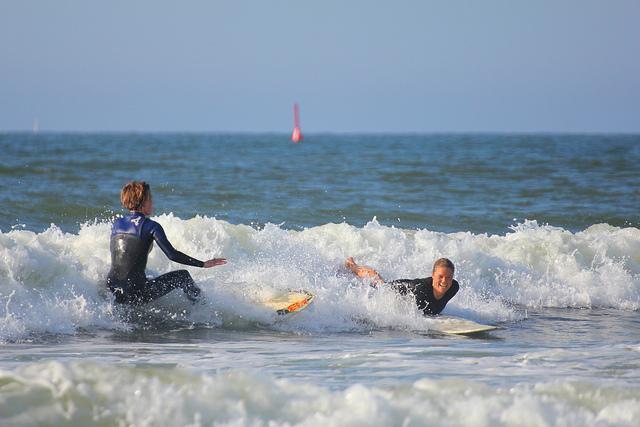How many people are shown?
Give a very brief answer. 2. How many people can be seen?
Give a very brief answer. 2. How many motorcycles are between the sidewalk and the yellow line in the road?
Give a very brief answer. 0. 